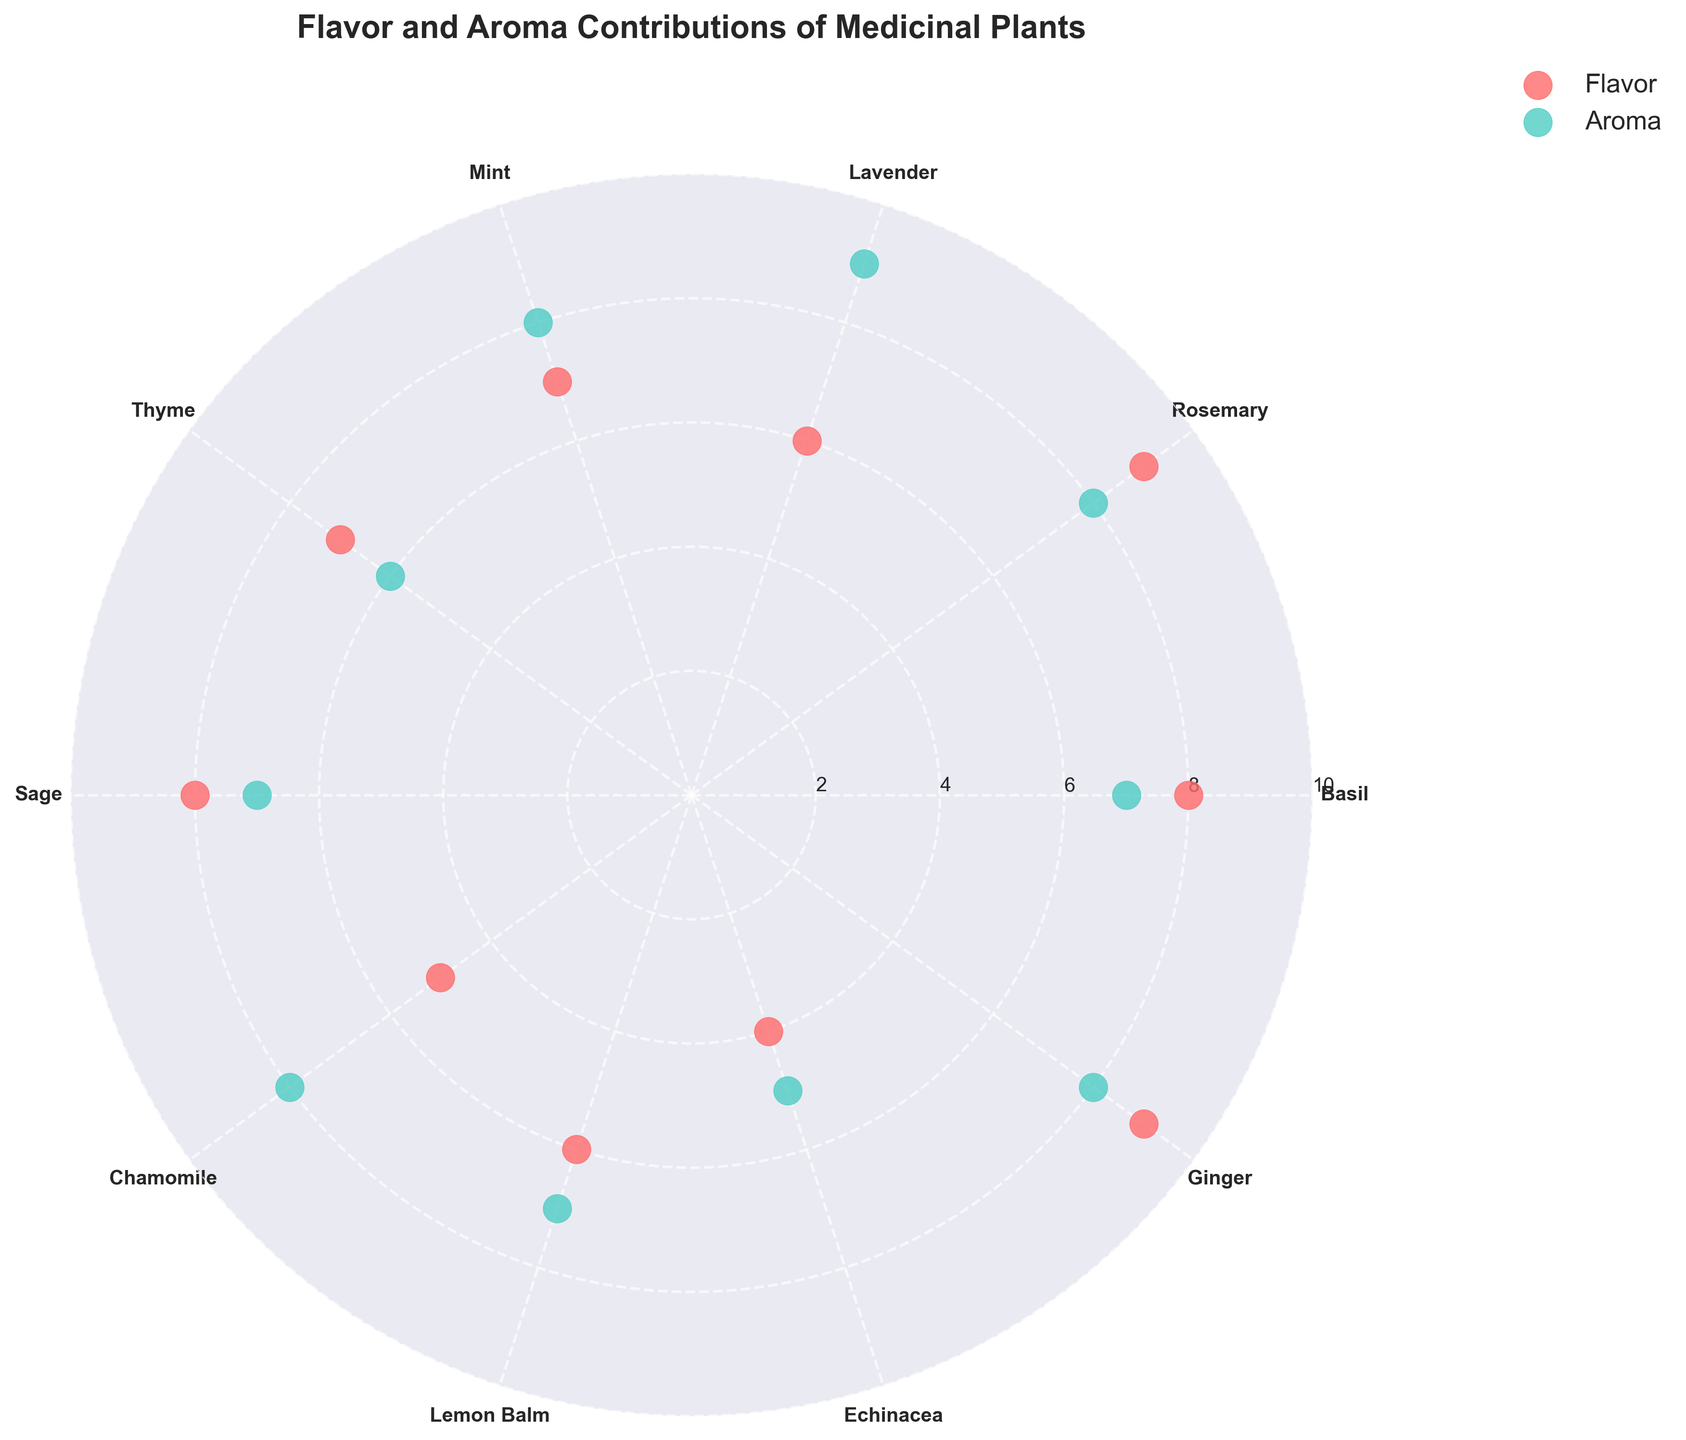What is the title of the chart? The title of the chart is located at the top center of the figure and provides an overview of what the chart represents. The title reads "Flavor and Aroma Contributions of Medicinal Plants".
Answer: Flavor and Aroma Contributions of Medicinal Plants Which plant has the highest flavor contribution? Look at the scatter points for flavor (likely colored in red). Identify which plant corresponds to the highest point on the flavor axis. The highest flavor contribution value is 9, which belongs to both Rosemary and Ginger.
Answer: Rosemary and Ginger What is the average Aroma Contribution value of all plants? To find the average, sum all the Aroma Contribution values and divide by the total number of plants. The Aroma Contribution values are [7, 8, 9, 8, 6, 7, 8, 7, 5, 8]. The sum is 73, and there are 10 plants. So, 73 divided by 10 equals 7.3.
Answer: 7.3 Which plant has both its Flavor and Aroma contributions above 8? Examine the scatter points and identify the plant(s) where both the Flavor and Aroma contributions are greater than 8. Only Rosemary has both contributions above 8 (Flavor = 9, Aroma = 8).
Answer: Rosemary How many plants have a Flavor Contribution of exactly 6? Identify the scatter points indicating a Flavor Contribution value of 6. Only Lavender and Lemon Balm have a Flavor Contribution of 6, so there are 2 plants.
Answer: 2 Which plant has the lowest aroma contribution and what is its value? Look for the scatter point with the lowest aroma value (likely colored in green) and find the corresponding plant. Echinacea has the lowest aroma contribution value of 5.
Answer: Echinacea, 5 Which plant has the closest values for both Flavor and Aroma contributions? Compare the differences between the Flavor and Aroma contributions for each plant. Chamomile has Flavor = 5 and Aroma = 8; the difference is 3. This suggests Chamomile has relatively close values compared to others.
Answer: Chamomile Are there more plants with Flavor Contribution greater than 7 or Aroma Contribution greater than 7? Count the number of plants where Flavor Contribution is greater than 7 and those where Aroma Contribution is greater than 7. For Flavor Contribution > 7: Basil, Rosemary, Sage, Ginger (4 plants). For Aroma Contribution > 7: Rosemary, Lavender, Mint, Chamomile, Ginger (5 plants).
Answer: Aroma Contribution What is the range of the Flavor Contribution values? The range is calculated as the difference between the highest and lowest values. The Flavor Contribution values have a maximum of 9 (Rosemary and Ginger) and a minimum of 4 (Echinacea). The range is 9 - 4, which equals 5.
Answer: 5 